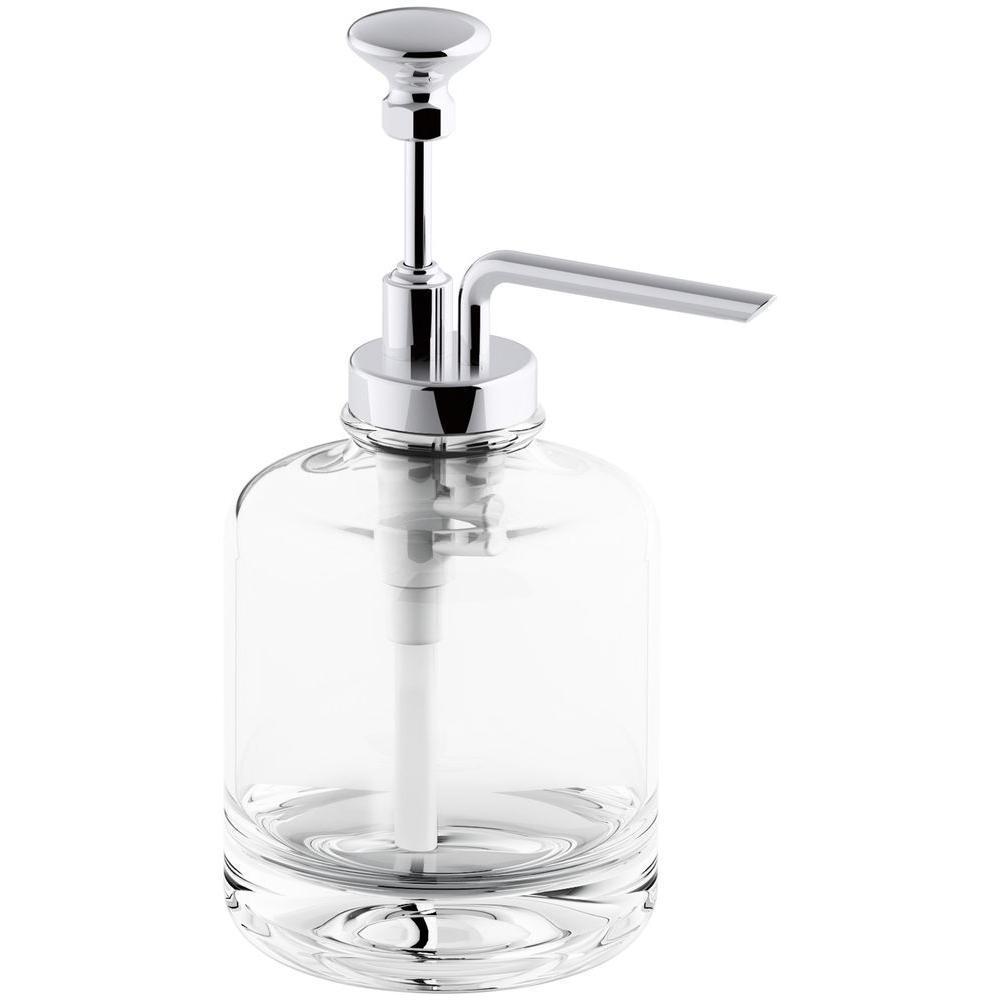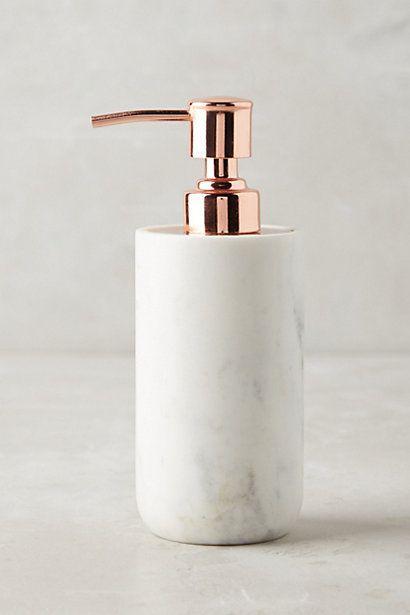The first image is the image on the left, the second image is the image on the right. For the images displayed, is the sentence "In one image soap is coming out of the dispenser." factually correct? Answer yes or no. No. The first image is the image on the left, the second image is the image on the right. Analyze the images presented: Is the assertion "An image contains a human hand obtaining soap from a dispenser." valid? Answer yes or no. No. 